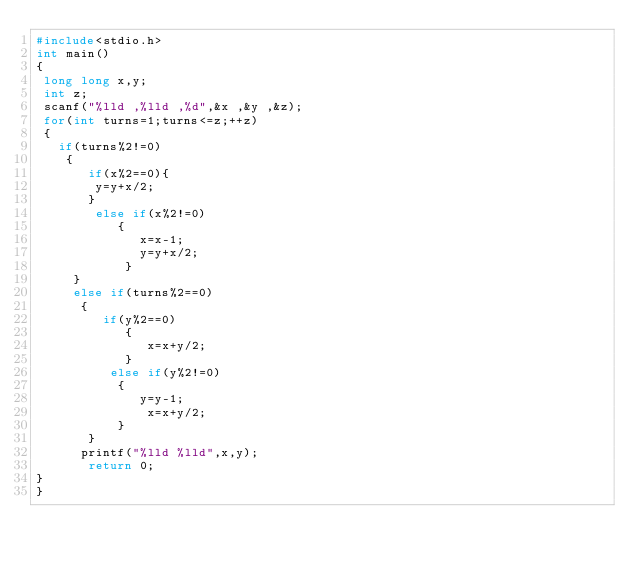<code> <loc_0><loc_0><loc_500><loc_500><_C_>#include<stdio.h>
int main()
{
 long long x,y;
 int z;
 scanf("%lld ,%lld ,%d",&x ,&y ,&z);
 for(int turns=1;turns<=z;++z)
 {
   if(turns%2!=0)
    {
       if(x%2==0){
        y=y+x/2;
       }
        else if(x%2!=0)
           {
              x=x-1;
              y=y+x/2;
            }
     }
     else if(turns%2==0)
      {
         if(y%2==0)
            {
               x=x+y/2;
            }
          else if(y%2!=0)
           {
              y=y-1;
               x=x+y/2;
           }
       }
      printf("%lld %lld",x,y);
       return 0;
} 
}</code> 